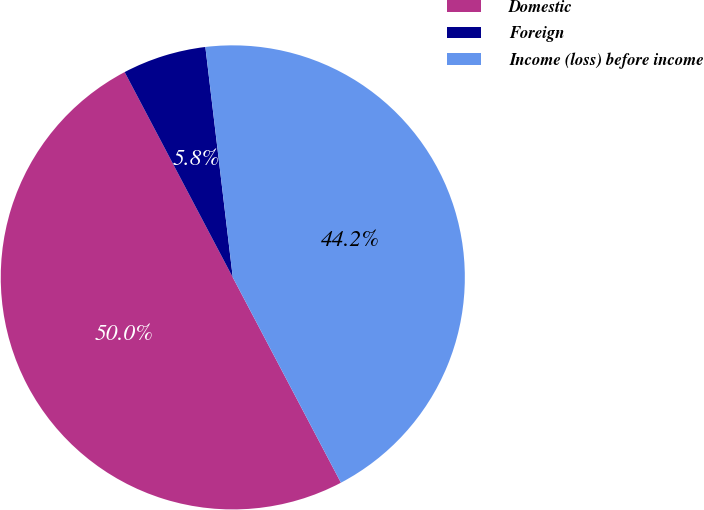Convert chart. <chart><loc_0><loc_0><loc_500><loc_500><pie_chart><fcel>Domestic<fcel>Foreign<fcel>Income (loss) before income<nl><fcel>50.0%<fcel>5.83%<fcel>44.17%<nl></chart> 